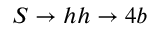<formula> <loc_0><loc_0><loc_500><loc_500>S \rightarrow h h \rightarrow 4 b</formula> 